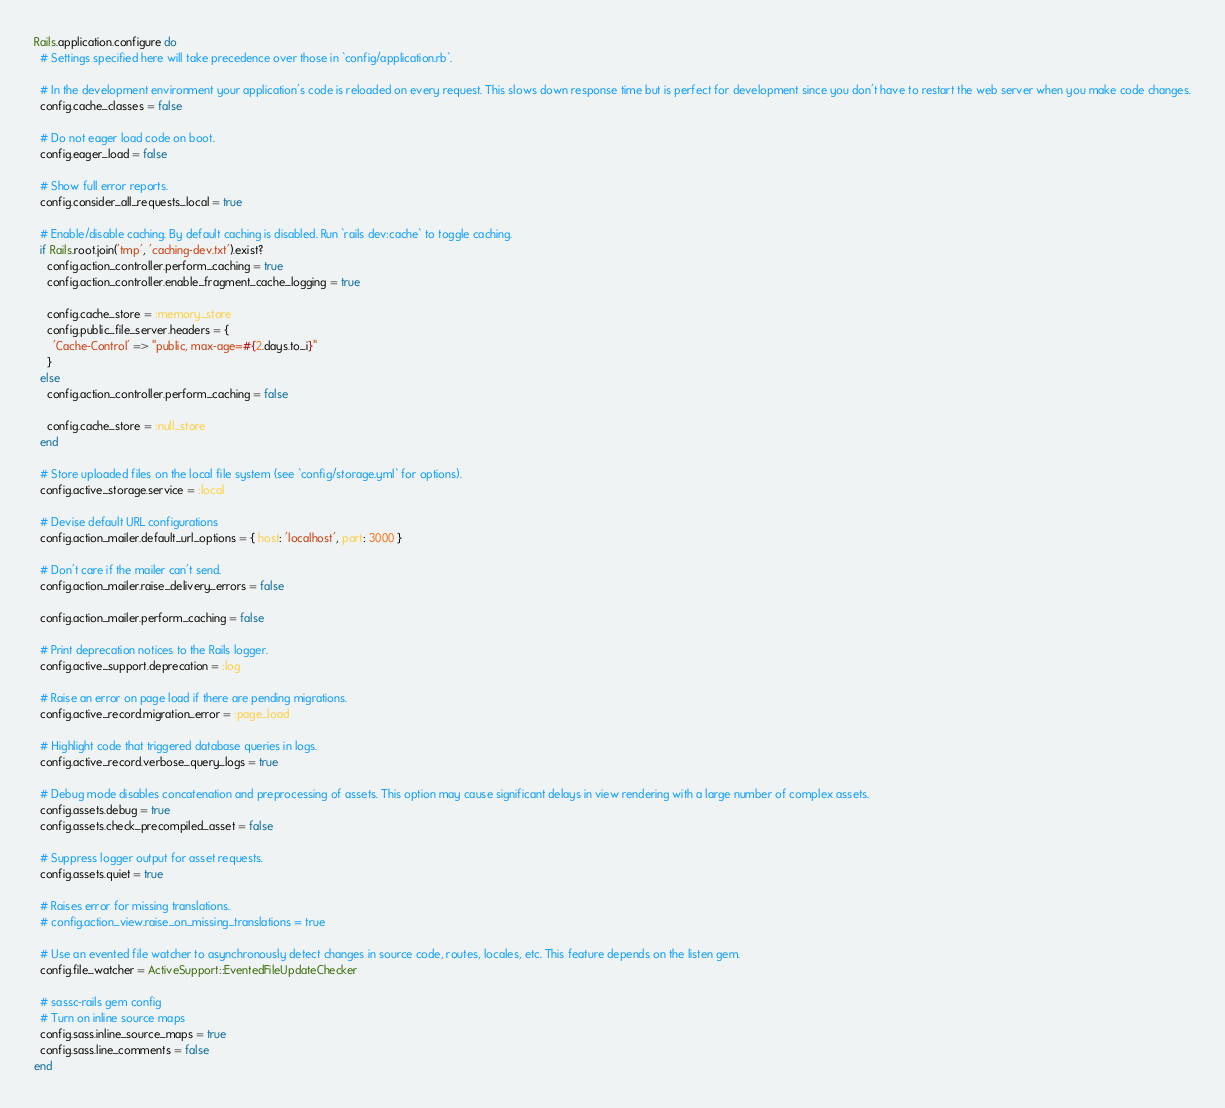<code> <loc_0><loc_0><loc_500><loc_500><_Ruby_>Rails.application.configure do
  # Settings specified here will take precedence over those in `config/application.rb`.

  # In the development environment your application's code is reloaded on every request. This slows down response time but is perfect for development since you don't have to restart the web server when you make code changes.
  config.cache_classes = false

  # Do not eager load code on boot.
  config.eager_load = false

  # Show full error reports.
  config.consider_all_requests_local = true

  # Enable/disable caching. By default caching is disabled. Run `rails dev:cache` to toggle caching.
  if Rails.root.join('tmp', 'caching-dev.txt').exist?
    config.action_controller.perform_caching = true
    config.action_controller.enable_fragment_cache_logging = true

    config.cache_store = :memory_store
    config.public_file_server.headers = {
      'Cache-Control' => "public, max-age=#{2.days.to_i}"
    }
  else
    config.action_controller.perform_caching = false

    config.cache_store = :null_store
  end

  # Store uploaded files on the local file system (see `config/storage.yml` for options).
  config.active_storage.service = :local

  # Devise default URL configurations
  config.action_mailer.default_url_options = { host: 'localhost', port: 3000 }

  # Don't care if the mailer can't send.
  config.action_mailer.raise_delivery_errors = false

  config.action_mailer.perform_caching = false

  # Print deprecation notices to the Rails logger.
  config.active_support.deprecation = :log

  # Raise an error on page load if there are pending migrations.
  config.active_record.migration_error = :page_load

  # Highlight code that triggered database queries in logs.
  config.active_record.verbose_query_logs = true

  # Debug mode disables concatenation and preprocessing of assets. This option may cause significant delays in view rendering with a large number of complex assets.
  config.assets.debug = true
  config.assets.check_precompiled_asset = false

  # Suppress logger output for asset requests.
  config.assets.quiet = true

  # Raises error for missing translations.
  # config.action_view.raise_on_missing_translations = true

  # Use an evented file watcher to asynchronously detect changes in source code, routes, locales, etc. This feature depends on the listen gem.
  config.file_watcher = ActiveSupport::EventedFileUpdateChecker

  # sassc-rails gem config
  # Turn on inline source maps
  config.sass.inline_source_maps = true
  config.sass.line_comments = false
end
</code> 